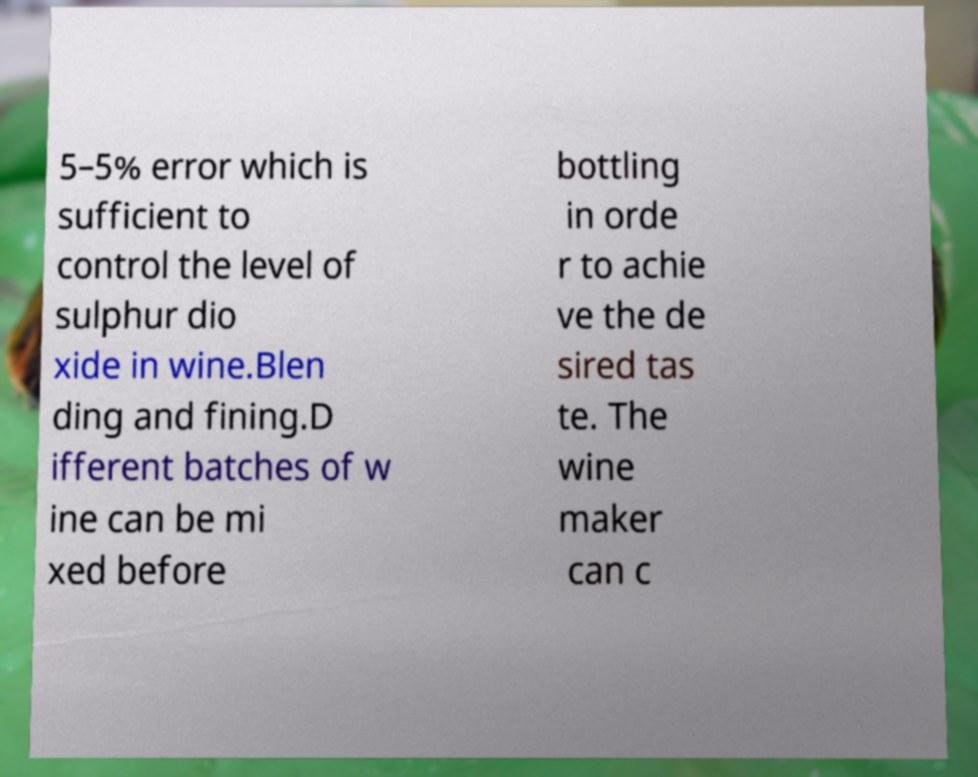Could you assist in decoding the text presented in this image and type it out clearly? 5–5% error which is sufficient to control the level of sulphur dio xide in wine.Blen ding and fining.D ifferent batches of w ine can be mi xed before bottling in orde r to achie ve the de sired tas te. The wine maker can c 